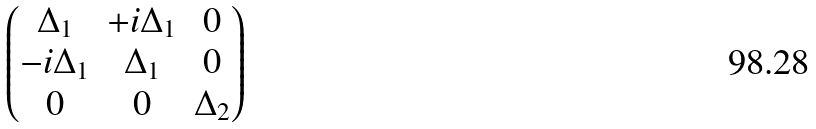<formula> <loc_0><loc_0><loc_500><loc_500>\begin{pmatrix} \Delta _ { 1 } & + i \Delta _ { 1 } & 0 \\ - i \Delta _ { 1 } & \Delta _ { 1 } & 0 \\ 0 & 0 & \Delta _ { 2 } \end{pmatrix}</formula> 